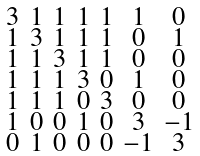<formula> <loc_0><loc_0><loc_500><loc_500>\begin{smallmatrix} 3 & 1 & 1 & 1 & 1 & 1 & 0 \\ 1 & 3 & 1 & 1 & 1 & 0 & 1 \\ 1 & 1 & 3 & 1 & 1 & 0 & 0 \\ 1 & 1 & 1 & 3 & 0 & 1 & 0 \\ 1 & 1 & 1 & 0 & 3 & 0 & 0 \\ 1 & 0 & 0 & 1 & 0 & 3 & - 1 \\ 0 & 1 & 0 & 0 & 0 & - 1 & 3 \end{smallmatrix}</formula> 